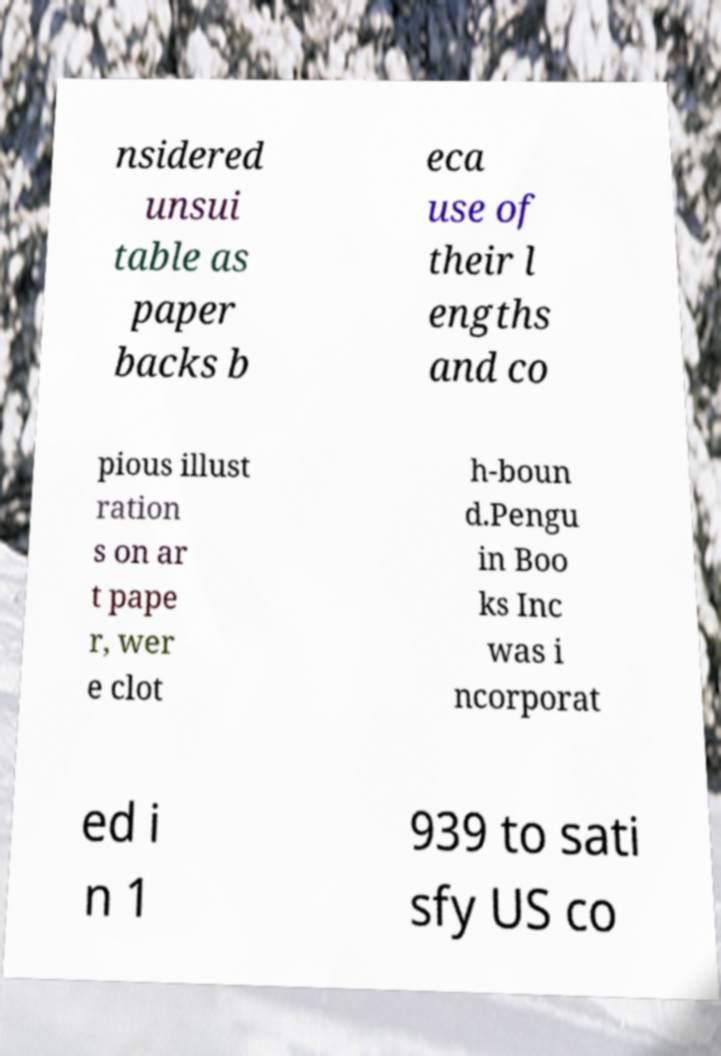Could you extract and type out the text from this image? nsidered unsui table as paper backs b eca use of their l engths and co pious illust ration s on ar t pape r, wer e clot h-boun d.Pengu in Boo ks Inc was i ncorporat ed i n 1 939 to sati sfy US co 